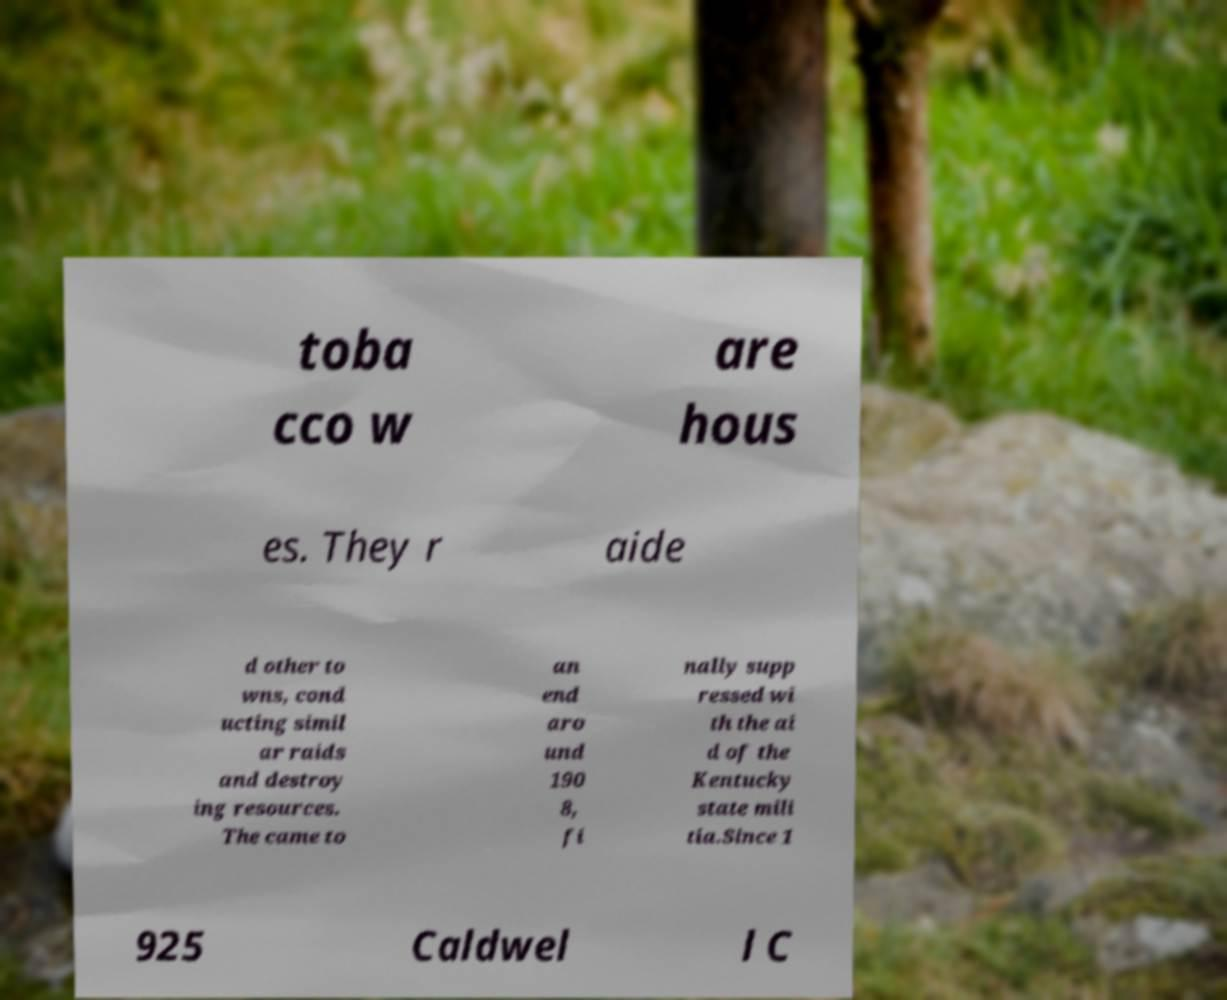Can you accurately transcribe the text from the provided image for me? toba cco w are hous es. They r aide d other to wns, cond ucting simil ar raids and destroy ing resources. The came to an end aro und 190 8, fi nally supp ressed wi th the ai d of the Kentucky state mili tia.Since 1 925 Caldwel l C 